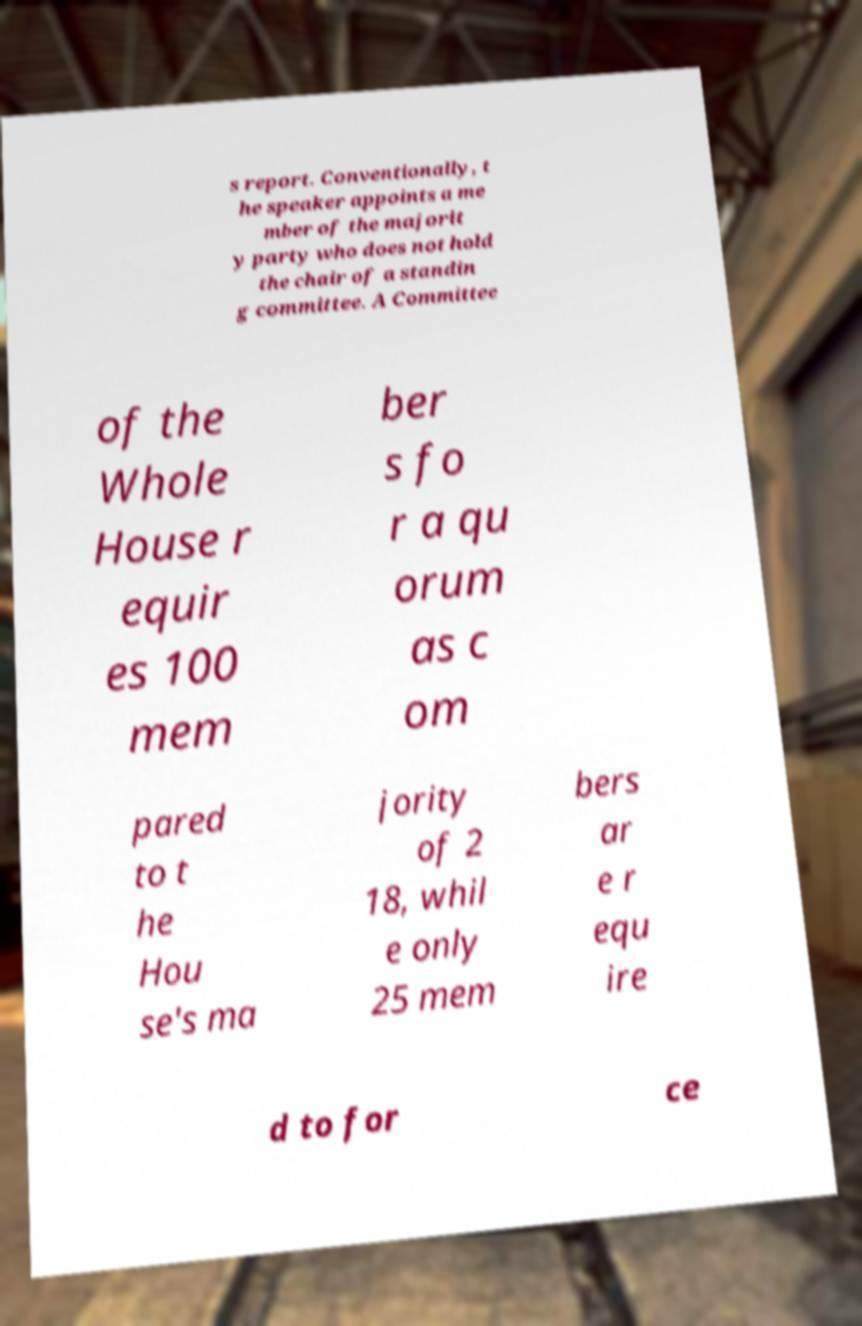Please read and relay the text visible in this image. What does it say? s report. Conventionally, t he speaker appoints a me mber of the majorit y party who does not hold the chair of a standin g committee. A Committee of the Whole House r equir es 100 mem ber s fo r a qu orum as c om pared to t he Hou se's ma jority of 2 18, whil e only 25 mem bers ar e r equ ire d to for ce 